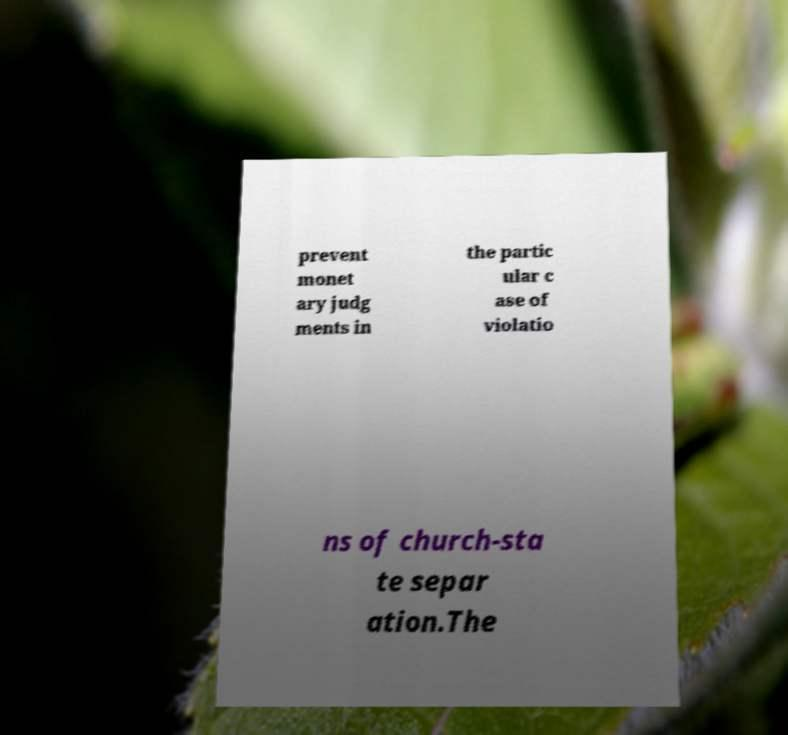Could you assist in decoding the text presented in this image and type it out clearly? prevent monet ary judg ments in the partic ular c ase of violatio ns of church-sta te separ ation.The 